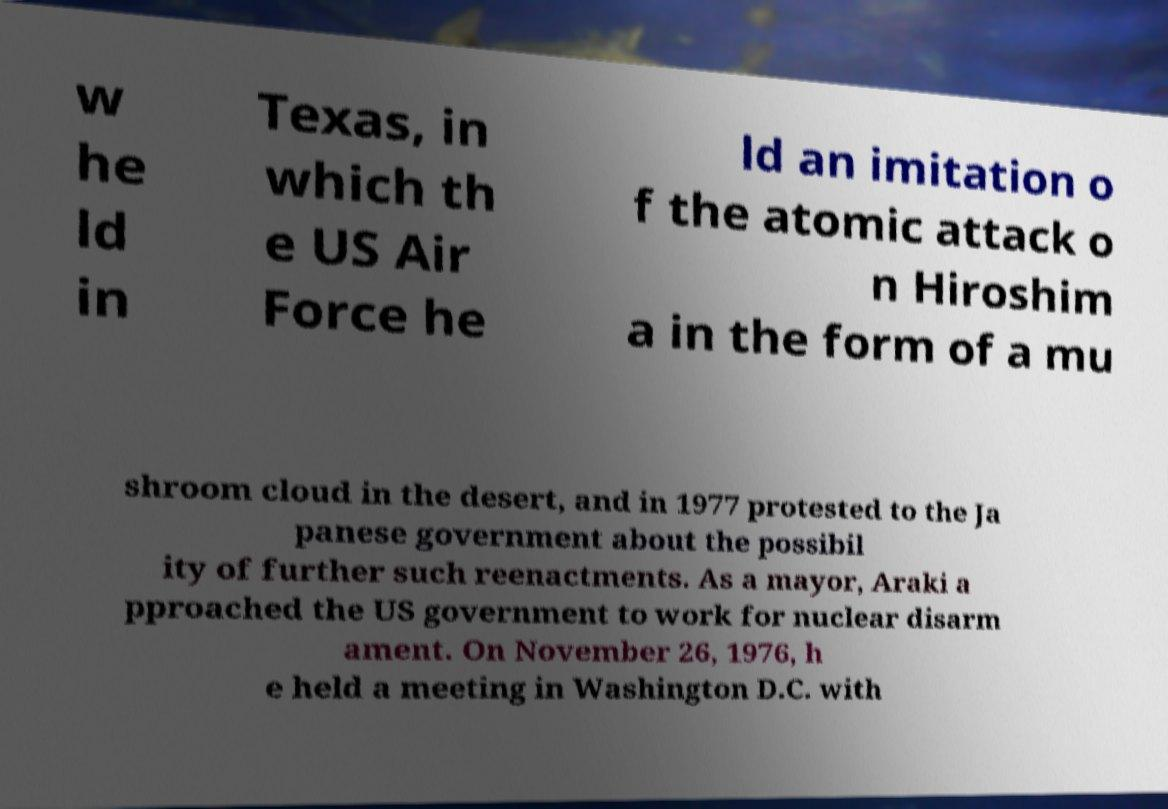I need the written content from this picture converted into text. Can you do that? w he ld in Texas, in which th e US Air Force he ld an imitation o f the atomic attack o n Hiroshim a in the form of a mu shroom cloud in the desert, and in 1977 protested to the Ja panese government about the possibil ity of further such reenactments. As a mayor, Araki a pproached the US government to work for nuclear disarm ament. On November 26, 1976, h e held a meeting in Washington D.C. with 